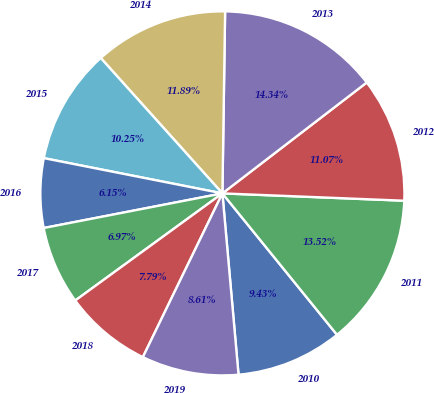Convert chart. <chart><loc_0><loc_0><loc_500><loc_500><pie_chart><fcel>2010<fcel>2011<fcel>2012<fcel>2013<fcel>2014<fcel>2015<fcel>2016<fcel>2017<fcel>2018<fcel>2019<nl><fcel>9.43%<fcel>13.52%<fcel>11.07%<fcel>14.34%<fcel>11.89%<fcel>10.25%<fcel>6.15%<fcel>6.97%<fcel>7.79%<fcel>8.61%<nl></chart> 